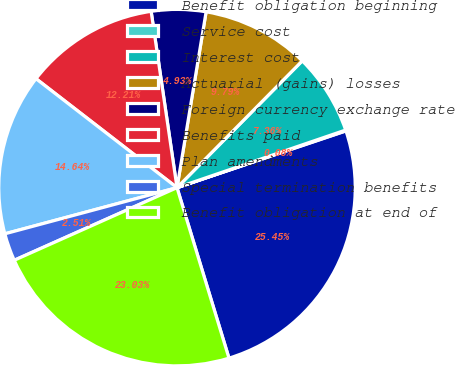Convert chart. <chart><loc_0><loc_0><loc_500><loc_500><pie_chart><fcel>Benefit obligation beginning<fcel>Service cost<fcel>Interest cost<fcel>Actuarial (gains) losses<fcel>Foreign currency exchange rate<fcel>Benefits paid<fcel>Plan amendments<fcel>Special termination benefits<fcel>Benefit obligation at end of<nl><fcel>25.45%<fcel>0.08%<fcel>7.36%<fcel>9.79%<fcel>4.93%<fcel>12.21%<fcel>14.64%<fcel>2.51%<fcel>23.03%<nl></chart> 